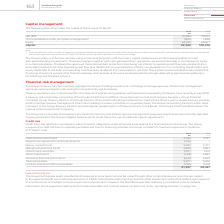From Vodafone Group Plc's financial document, What does the Group's capital comprise of? The document contains multiple relevant values: Net debt, Financial liabilities under put option arrangements, Equity. From the document: "2019 2018 €m €m Net debt 27,033 29,631 Financial liabilities under put option arrangements 1 1,844 1,838 Equity 63,445 68,60 ities under put option ar..." Also, What does the table show? the capital of the Group at 31 March. The document states: "Capital management The following table summarises the capital of the Group at 31 March:..." Also, How much is the 2019 net debt? According to the financial document, 27,033 (in millions). The relevant text states: "2019 2018 €m €m Net debt 27,033 29,631 Financial liabilities under put option arrangements 1 1,844 1,838 Equity 63,445 68,607 Capit..." Additionally, Between 2018 and 2019, which year had higher net debt? According to the financial document, 2018. The relevant text states: "2019 2018 €m €m Net debt 27,033 29,631 Financial liabilities under put option arrangements 1 1,844 1,838 Equi..." Additionally, Between 2018 and 2019, which year had a higher amount of equity?  According to the financial document, 2018. The relevant text states: "2019 2018 €m €m Net debt 27,033 29,631 Financial liabilities under put option arrangements 1 1,844 1,838 Equi..." Additionally, Between 2018 and 2019, which year had a greater amount of capital? According to the financial document, 2018. The relevant text states: "2019 2018 €m €m Net debt 27,033 29,631 Financial liabilities under put option arrangements 1 1,844 1,838 Equi..." 